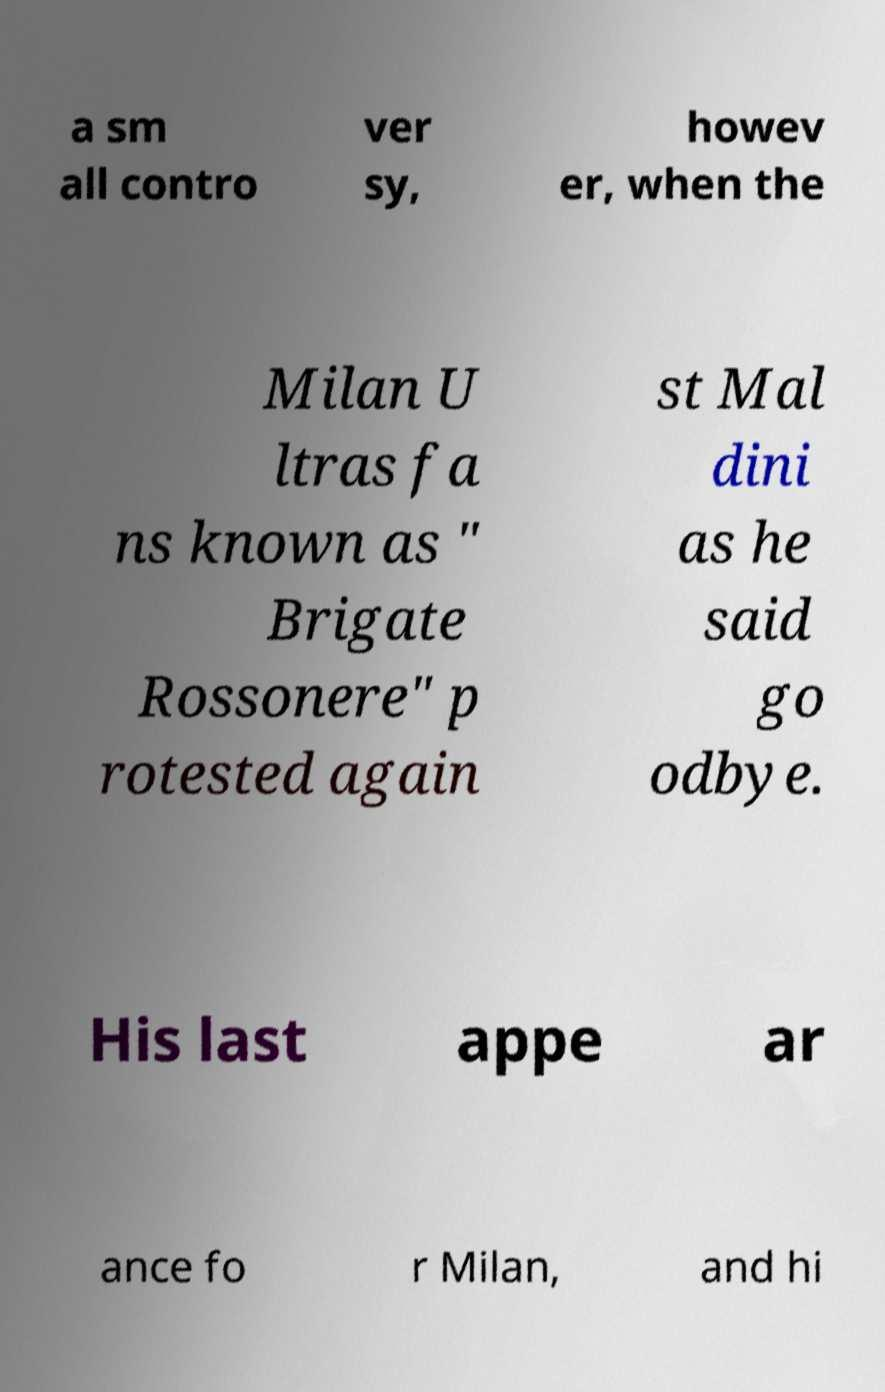Could you assist in decoding the text presented in this image and type it out clearly? a sm all contro ver sy, howev er, when the Milan U ltras fa ns known as " Brigate Rossonere" p rotested again st Mal dini as he said go odbye. His last appe ar ance fo r Milan, and hi 